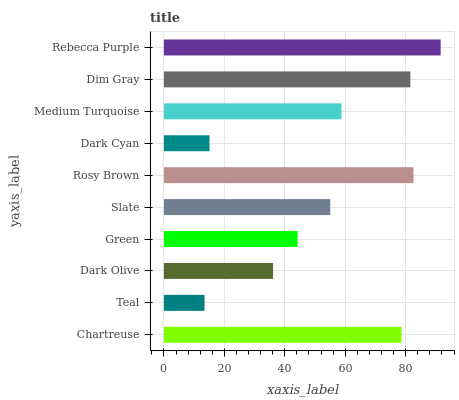Is Teal the minimum?
Answer yes or no. Yes. Is Rebecca Purple the maximum?
Answer yes or no. Yes. Is Dark Olive the minimum?
Answer yes or no. No. Is Dark Olive the maximum?
Answer yes or no. No. Is Dark Olive greater than Teal?
Answer yes or no. Yes. Is Teal less than Dark Olive?
Answer yes or no. Yes. Is Teal greater than Dark Olive?
Answer yes or no. No. Is Dark Olive less than Teal?
Answer yes or no. No. Is Medium Turquoise the high median?
Answer yes or no. Yes. Is Slate the low median?
Answer yes or no. Yes. Is Rosy Brown the high median?
Answer yes or no. No. Is Medium Turquoise the low median?
Answer yes or no. No. 